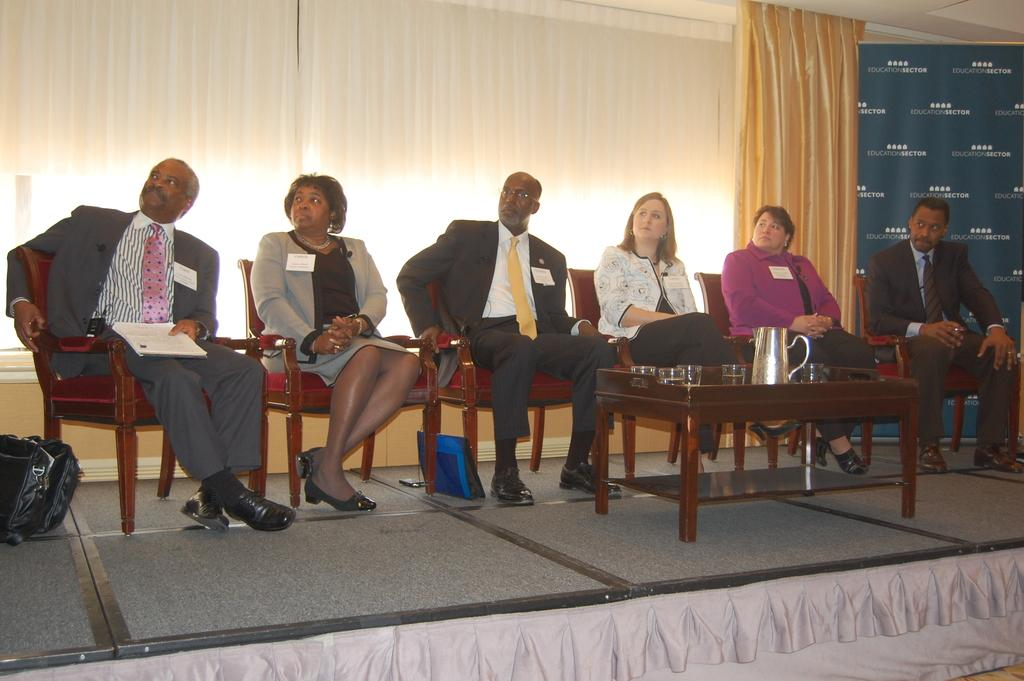What type of furniture is present in the image? There is a table in the image. What is the person in the image doing? The person is sitting on chairs. What can be seen in the background of the image? There are curtains in the background. What is on the table in the image? There is a jug and glasses on the table. What is the person holding in the image? The person is holding papers. What type of church can be seen in the background of the image? There is no church present in the background of the image. What kind of pest is visible on the table in the image? There are no pests visible on the table in the image. 